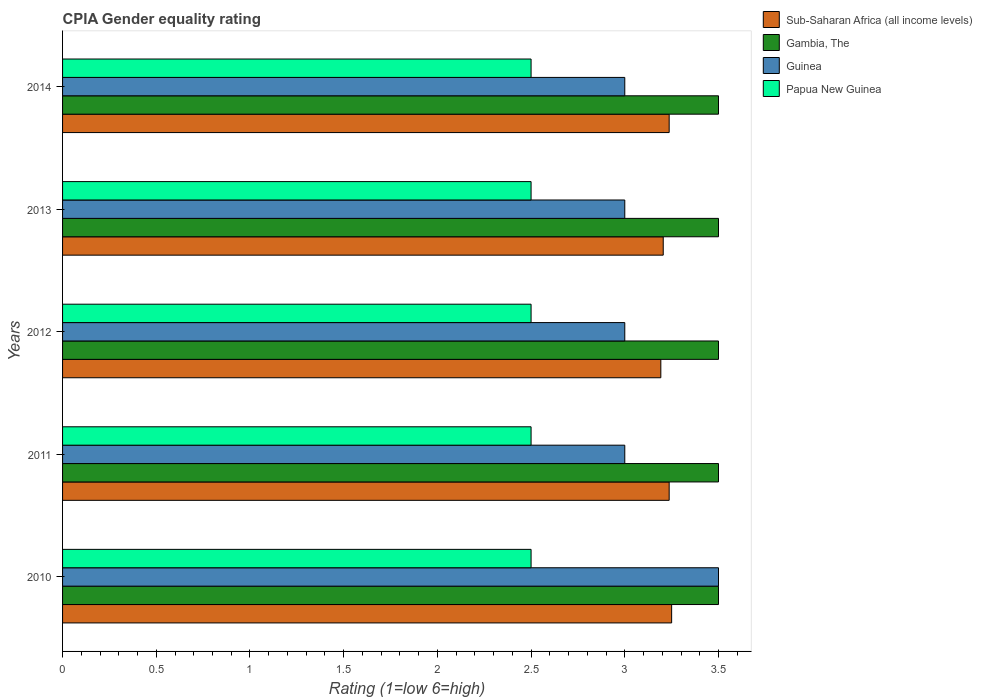How many different coloured bars are there?
Offer a terse response. 4. Are the number of bars per tick equal to the number of legend labels?
Your response must be concise. Yes. Are the number of bars on each tick of the Y-axis equal?
Offer a terse response. Yes. In how many cases, is the number of bars for a given year not equal to the number of legend labels?
Give a very brief answer. 0. Across all years, what is the minimum CPIA rating in Gambia, The?
Your answer should be compact. 3.5. What is the total CPIA rating in Sub-Saharan Africa (all income levels) in the graph?
Offer a very short reply. 16.12. What is the difference between the CPIA rating in Sub-Saharan Africa (all income levels) in 2011 and that in 2012?
Provide a short and direct response. 0.04. In the year 2014, what is the difference between the CPIA rating in Sub-Saharan Africa (all income levels) and CPIA rating in Papua New Guinea?
Provide a succinct answer. 0.74. What is the ratio of the CPIA rating in Guinea in 2011 to that in 2013?
Your response must be concise. 1. Is the CPIA rating in Papua New Guinea in 2010 less than that in 2014?
Keep it short and to the point. No. Is the difference between the CPIA rating in Sub-Saharan Africa (all income levels) in 2011 and 2013 greater than the difference between the CPIA rating in Papua New Guinea in 2011 and 2013?
Your answer should be very brief. Yes. What is the difference between the highest and the second highest CPIA rating in Sub-Saharan Africa (all income levels)?
Your response must be concise. 0.01. What is the difference between the highest and the lowest CPIA rating in Sub-Saharan Africa (all income levels)?
Make the answer very short. 0.06. In how many years, is the CPIA rating in Sub-Saharan Africa (all income levels) greater than the average CPIA rating in Sub-Saharan Africa (all income levels) taken over all years?
Provide a succinct answer. 3. Is the sum of the CPIA rating in Gambia, The in 2012 and 2013 greater than the maximum CPIA rating in Papua New Guinea across all years?
Offer a very short reply. Yes. What does the 4th bar from the top in 2013 represents?
Offer a very short reply. Sub-Saharan Africa (all income levels). What does the 2nd bar from the bottom in 2012 represents?
Your answer should be very brief. Gambia, The. How many bars are there?
Ensure brevity in your answer.  20. What is the difference between two consecutive major ticks on the X-axis?
Your answer should be compact. 0.5. How many legend labels are there?
Keep it short and to the point. 4. What is the title of the graph?
Give a very brief answer. CPIA Gender equality rating. Does "Bosnia and Herzegovina" appear as one of the legend labels in the graph?
Offer a terse response. No. What is the label or title of the Y-axis?
Keep it short and to the point. Years. What is the Rating (1=low 6=high) in Gambia, The in 2010?
Your answer should be very brief. 3.5. What is the Rating (1=low 6=high) in Sub-Saharan Africa (all income levels) in 2011?
Provide a short and direct response. 3.24. What is the Rating (1=low 6=high) of Gambia, The in 2011?
Your answer should be very brief. 3.5. What is the Rating (1=low 6=high) in Papua New Guinea in 2011?
Your response must be concise. 2.5. What is the Rating (1=low 6=high) of Sub-Saharan Africa (all income levels) in 2012?
Offer a terse response. 3.19. What is the Rating (1=low 6=high) of Guinea in 2012?
Offer a terse response. 3. What is the Rating (1=low 6=high) in Papua New Guinea in 2012?
Your answer should be compact. 2.5. What is the Rating (1=low 6=high) in Sub-Saharan Africa (all income levels) in 2013?
Ensure brevity in your answer.  3.21. What is the Rating (1=low 6=high) in Gambia, The in 2013?
Ensure brevity in your answer.  3.5. What is the Rating (1=low 6=high) in Papua New Guinea in 2013?
Keep it short and to the point. 2.5. What is the Rating (1=low 6=high) of Sub-Saharan Africa (all income levels) in 2014?
Provide a succinct answer. 3.24. What is the Rating (1=low 6=high) of Gambia, The in 2014?
Offer a very short reply. 3.5. Across all years, what is the maximum Rating (1=low 6=high) of Guinea?
Your answer should be very brief. 3.5. Across all years, what is the maximum Rating (1=low 6=high) in Papua New Guinea?
Ensure brevity in your answer.  2.5. Across all years, what is the minimum Rating (1=low 6=high) in Sub-Saharan Africa (all income levels)?
Offer a very short reply. 3.19. Across all years, what is the minimum Rating (1=low 6=high) in Guinea?
Your answer should be compact. 3. What is the total Rating (1=low 6=high) of Sub-Saharan Africa (all income levels) in the graph?
Offer a terse response. 16.12. What is the total Rating (1=low 6=high) of Gambia, The in the graph?
Ensure brevity in your answer.  17.5. What is the difference between the Rating (1=low 6=high) in Sub-Saharan Africa (all income levels) in 2010 and that in 2011?
Provide a short and direct response. 0.01. What is the difference between the Rating (1=low 6=high) of Guinea in 2010 and that in 2011?
Your response must be concise. 0.5. What is the difference between the Rating (1=low 6=high) of Sub-Saharan Africa (all income levels) in 2010 and that in 2012?
Provide a succinct answer. 0.06. What is the difference between the Rating (1=low 6=high) of Gambia, The in 2010 and that in 2012?
Provide a short and direct response. 0. What is the difference between the Rating (1=low 6=high) of Guinea in 2010 and that in 2012?
Offer a very short reply. 0.5. What is the difference between the Rating (1=low 6=high) of Papua New Guinea in 2010 and that in 2012?
Your answer should be very brief. 0. What is the difference between the Rating (1=low 6=high) in Sub-Saharan Africa (all income levels) in 2010 and that in 2013?
Make the answer very short. 0.04. What is the difference between the Rating (1=low 6=high) in Gambia, The in 2010 and that in 2013?
Ensure brevity in your answer.  0. What is the difference between the Rating (1=low 6=high) in Guinea in 2010 and that in 2013?
Keep it short and to the point. 0.5. What is the difference between the Rating (1=low 6=high) of Papua New Guinea in 2010 and that in 2013?
Provide a succinct answer. 0. What is the difference between the Rating (1=low 6=high) in Sub-Saharan Africa (all income levels) in 2010 and that in 2014?
Your response must be concise. 0.01. What is the difference between the Rating (1=low 6=high) of Sub-Saharan Africa (all income levels) in 2011 and that in 2012?
Your answer should be very brief. 0.04. What is the difference between the Rating (1=low 6=high) of Guinea in 2011 and that in 2012?
Keep it short and to the point. 0. What is the difference between the Rating (1=low 6=high) in Sub-Saharan Africa (all income levels) in 2011 and that in 2013?
Keep it short and to the point. 0.03. What is the difference between the Rating (1=low 6=high) of Gambia, The in 2011 and that in 2013?
Your answer should be compact. 0. What is the difference between the Rating (1=low 6=high) in Guinea in 2011 and that in 2013?
Your answer should be compact. 0. What is the difference between the Rating (1=low 6=high) in Papua New Guinea in 2011 and that in 2013?
Offer a terse response. 0. What is the difference between the Rating (1=low 6=high) of Sub-Saharan Africa (all income levels) in 2011 and that in 2014?
Provide a short and direct response. 0. What is the difference between the Rating (1=low 6=high) of Gambia, The in 2011 and that in 2014?
Offer a very short reply. 0. What is the difference between the Rating (1=low 6=high) of Papua New Guinea in 2011 and that in 2014?
Offer a terse response. 0. What is the difference between the Rating (1=low 6=high) of Sub-Saharan Africa (all income levels) in 2012 and that in 2013?
Give a very brief answer. -0.01. What is the difference between the Rating (1=low 6=high) in Sub-Saharan Africa (all income levels) in 2012 and that in 2014?
Keep it short and to the point. -0.04. What is the difference between the Rating (1=low 6=high) in Gambia, The in 2012 and that in 2014?
Your answer should be very brief. 0. What is the difference between the Rating (1=low 6=high) in Papua New Guinea in 2012 and that in 2014?
Make the answer very short. 0. What is the difference between the Rating (1=low 6=high) in Sub-Saharan Africa (all income levels) in 2013 and that in 2014?
Ensure brevity in your answer.  -0.03. What is the difference between the Rating (1=low 6=high) of Gambia, The in 2013 and that in 2014?
Give a very brief answer. 0. What is the difference between the Rating (1=low 6=high) in Papua New Guinea in 2013 and that in 2014?
Your answer should be very brief. 0. What is the difference between the Rating (1=low 6=high) of Sub-Saharan Africa (all income levels) in 2010 and the Rating (1=low 6=high) of Gambia, The in 2011?
Offer a terse response. -0.25. What is the difference between the Rating (1=low 6=high) in Sub-Saharan Africa (all income levels) in 2010 and the Rating (1=low 6=high) in Guinea in 2011?
Offer a very short reply. 0.25. What is the difference between the Rating (1=low 6=high) of Sub-Saharan Africa (all income levels) in 2010 and the Rating (1=low 6=high) of Papua New Guinea in 2011?
Keep it short and to the point. 0.75. What is the difference between the Rating (1=low 6=high) of Guinea in 2010 and the Rating (1=low 6=high) of Papua New Guinea in 2011?
Provide a short and direct response. 1. What is the difference between the Rating (1=low 6=high) of Sub-Saharan Africa (all income levels) in 2010 and the Rating (1=low 6=high) of Papua New Guinea in 2012?
Give a very brief answer. 0.75. What is the difference between the Rating (1=low 6=high) of Guinea in 2010 and the Rating (1=low 6=high) of Papua New Guinea in 2012?
Offer a very short reply. 1. What is the difference between the Rating (1=low 6=high) in Guinea in 2010 and the Rating (1=low 6=high) in Papua New Guinea in 2013?
Your answer should be compact. 1. What is the difference between the Rating (1=low 6=high) in Sub-Saharan Africa (all income levels) in 2010 and the Rating (1=low 6=high) in Gambia, The in 2014?
Offer a very short reply. -0.25. What is the difference between the Rating (1=low 6=high) of Sub-Saharan Africa (all income levels) in 2010 and the Rating (1=low 6=high) of Papua New Guinea in 2014?
Your response must be concise. 0.75. What is the difference between the Rating (1=low 6=high) in Sub-Saharan Africa (all income levels) in 2011 and the Rating (1=low 6=high) in Gambia, The in 2012?
Your answer should be compact. -0.26. What is the difference between the Rating (1=low 6=high) of Sub-Saharan Africa (all income levels) in 2011 and the Rating (1=low 6=high) of Guinea in 2012?
Keep it short and to the point. 0.24. What is the difference between the Rating (1=low 6=high) in Sub-Saharan Africa (all income levels) in 2011 and the Rating (1=low 6=high) in Papua New Guinea in 2012?
Give a very brief answer. 0.74. What is the difference between the Rating (1=low 6=high) of Gambia, The in 2011 and the Rating (1=low 6=high) of Guinea in 2012?
Keep it short and to the point. 0.5. What is the difference between the Rating (1=low 6=high) in Sub-Saharan Africa (all income levels) in 2011 and the Rating (1=low 6=high) in Gambia, The in 2013?
Ensure brevity in your answer.  -0.26. What is the difference between the Rating (1=low 6=high) in Sub-Saharan Africa (all income levels) in 2011 and the Rating (1=low 6=high) in Guinea in 2013?
Offer a very short reply. 0.24. What is the difference between the Rating (1=low 6=high) of Sub-Saharan Africa (all income levels) in 2011 and the Rating (1=low 6=high) of Papua New Guinea in 2013?
Keep it short and to the point. 0.74. What is the difference between the Rating (1=low 6=high) of Guinea in 2011 and the Rating (1=low 6=high) of Papua New Guinea in 2013?
Offer a terse response. 0.5. What is the difference between the Rating (1=low 6=high) of Sub-Saharan Africa (all income levels) in 2011 and the Rating (1=low 6=high) of Gambia, The in 2014?
Provide a short and direct response. -0.26. What is the difference between the Rating (1=low 6=high) of Sub-Saharan Africa (all income levels) in 2011 and the Rating (1=low 6=high) of Guinea in 2014?
Your answer should be very brief. 0.24. What is the difference between the Rating (1=low 6=high) in Sub-Saharan Africa (all income levels) in 2011 and the Rating (1=low 6=high) in Papua New Guinea in 2014?
Keep it short and to the point. 0.74. What is the difference between the Rating (1=low 6=high) in Gambia, The in 2011 and the Rating (1=low 6=high) in Guinea in 2014?
Your response must be concise. 0.5. What is the difference between the Rating (1=low 6=high) of Gambia, The in 2011 and the Rating (1=low 6=high) of Papua New Guinea in 2014?
Your answer should be very brief. 1. What is the difference between the Rating (1=low 6=high) in Guinea in 2011 and the Rating (1=low 6=high) in Papua New Guinea in 2014?
Make the answer very short. 0.5. What is the difference between the Rating (1=low 6=high) in Sub-Saharan Africa (all income levels) in 2012 and the Rating (1=low 6=high) in Gambia, The in 2013?
Give a very brief answer. -0.31. What is the difference between the Rating (1=low 6=high) in Sub-Saharan Africa (all income levels) in 2012 and the Rating (1=low 6=high) in Guinea in 2013?
Provide a short and direct response. 0.19. What is the difference between the Rating (1=low 6=high) in Sub-Saharan Africa (all income levels) in 2012 and the Rating (1=low 6=high) in Papua New Guinea in 2013?
Offer a very short reply. 0.69. What is the difference between the Rating (1=low 6=high) of Gambia, The in 2012 and the Rating (1=low 6=high) of Guinea in 2013?
Provide a succinct answer. 0.5. What is the difference between the Rating (1=low 6=high) in Guinea in 2012 and the Rating (1=low 6=high) in Papua New Guinea in 2013?
Your response must be concise. 0.5. What is the difference between the Rating (1=low 6=high) in Sub-Saharan Africa (all income levels) in 2012 and the Rating (1=low 6=high) in Gambia, The in 2014?
Offer a very short reply. -0.31. What is the difference between the Rating (1=low 6=high) of Sub-Saharan Africa (all income levels) in 2012 and the Rating (1=low 6=high) of Guinea in 2014?
Provide a short and direct response. 0.19. What is the difference between the Rating (1=low 6=high) in Sub-Saharan Africa (all income levels) in 2012 and the Rating (1=low 6=high) in Papua New Guinea in 2014?
Offer a very short reply. 0.69. What is the difference between the Rating (1=low 6=high) of Gambia, The in 2012 and the Rating (1=low 6=high) of Guinea in 2014?
Keep it short and to the point. 0.5. What is the difference between the Rating (1=low 6=high) of Guinea in 2012 and the Rating (1=low 6=high) of Papua New Guinea in 2014?
Make the answer very short. 0.5. What is the difference between the Rating (1=low 6=high) in Sub-Saharan Africa (all income levels) in 2013 and the Rating (1=low 6=high) in Gambia, The in 2014?
Offer a terse response. -0.29. What is the difference between the Rating (1=low 6=high) in Sub-Saharan Africa (all income levels) in 2013 and the Rating (1=low 6=high) in Guinea in 2014?
Offer a terse response. 0.21. What is the difference between the Rating (1=low 6=high) of Sub-Saharan Africa (all income levels) in 2013 and the Rating (1=low 6=high) of Papua New Guinea in 2014?
Your answer should be compact. 0.71. What is the difference between the Rating (1=low 6=high) in Gambia, The in 2013 and the Rating (1=low 6=high) in Guinea in 2014?
Give a very brief answer. 0.5. What is the difference between the Rating (1=low 6=high) in Gambia, The in 2013 and the Rating (1=low 6=high) in Papua New Guinea in 2014?
Make the answer very short. 1. What is the difference between the Rating (1=low 6=high) in Guinea in 2013 and the Rating (1=low 6=high) in Papua New Guinea in 2014?
Ensure brevity in your answer.  0.5. What is the average Rating (1=low 6=high) in Sub-Saharan Africa (all income levels) per year?
Ensure brevity in your answer.  3.22. What is the average Rating (1=low 6=high) of Guinea per year?
Provide a succinct answer. 3.1. In the year 2010, what is the difference between the Rating (1=low 6=high) in Gambia, The and Rating (1=low 6=high) in Papua New Guinea?
Your answer should be compact. 1. In the year 2010, what is the difference between the Rating (1=low 6=high) of Guinea and Rating (1=low 6=high) of Papua New Guinea?
Provide a short and direct response. 1. In the year 2011, what is the difference between the Rating (1=low 6=high) of Sub-Saharan Africa (all income levels) and Rating (1=low 6=high) of Gambia, The?
Offer a very short reply. -0.26. In the year 2011, what is the difference between the Rating (1=low 6=high) in Sub-Saharan Africa (all income levels) and Rating (1=low 6=high) in Guinea?
Give a very brief answer. 0.24. In the year 2011, what is the difference between the Rating (1=low 6=high) in Sub-Saharan Africa (all income levels) and Rating (1=low 6=high) in Papua New Guinea?
Offer a terse response. 0.74. In the year 2011, what is the difference between the Rating (1=low 6=high) of Gambia, The and Rating (1=low 6=high) of Papua New Guinea?
Make the answer very short. 1. In the year 2011, what is the difference between the Rating (1=low 6=high) of Guinea and Rating (1=low 6=high) of Papua New Guinea?
Your answer should be compact. 0.5. In the year 2012, what is the difference between the Rating (1=low 6=high) in Sub-Saharan Africa (all income levels) and Rating (1=low 6=high) in Gambia, The?
Ensure brevity in your answer.  -0.31. In the year 2012, what is the difference between the Rating (1=low 6=high) in Sub-Saharan Africa (all income levels) and Rating (1=low 6=high) in Guinea?
Your answer should be very brief. 0.19. In the year 2012, what is the difference between the Rating (1=low 6=high) in Sub-Saharan Africa (all income levels) and Rating (1=low 6=high) in Papua New Guinea?
Offer a very short reply. 0.69. In the year 2012, what is the difference between the Rating (1=low 6=high) of Gambia, The and Rating (1=low 6=high) of Guinea?
Provide a short and direct response. 0.5. In the year 2012, what is the difference between the Rating (1=low 6=high) in Guinea and Rating (1=low 6=high) in Papua New Guinea?
Offer a terse response. 0.5. In the year 2013, what is the difference between the Rating (1=low 6=high) of Sub-Saharan Africa (all income levels) and Rating (1=low 6=high) of Gambia, The?
Offer a terse response. -0.29. In the year 2013, what is the difference between the Rating (1=low 6=high) of Sub-Saharan Africa (all income levels) and Rating (1=low 6=high) of Guinea?
Ensure brevity in your answer.  0.21. In the year 2013, what is the difference between the Rating (1=low 6=high) in Sub-Saharan Africa (all income levels) and Rating (1=low 6=high) in Papua New Guinea?
Provide a short and direct response. 0.71. In the year 2013, what is the difference between the Rating (1=low 6=high) of Gambia, The and Rating (1=low 6=high) of Guinea?
Your response must be concise. 0.5. In the year 2013, what is the difference between the Rating (1=low 6=high) of Gambia, The and Rating (1=low 6=high) of Papua New Guinea?
Give a very brief answer. 1. In the year 2013, what is the difference between the Rating (1=low 6=high) in Guinea and Rating (1=low 6=high) in Papua New Guinea?
Ensure brevity in your answer.  0.5. In the year 2014, what is the difference between the Rating (1=low 6=high) in Sub-Saharan Africa (all income levels) and Rating (1=low 6=high) in Gambia, The?
Provide a succinct answer. -0.26. In the year 2014, what is the difference between the Rating (1=low 6=high) in Sub-Saharan Africa (all income levels) and Rating (1=low 6=high) in Guinea?
Give a very brief answer. 0.24. In the year 2014, what is the difference between the Rating (1=low 6=high) of Sub-Saharan Africa (all income levels) and Rating (1=low 6=high) of Papua New Guinea?
Keep it short and to the point. 0.74. In the year 2014, what is the difference between the Rating (1=low 6=high) of Gambia, The and Rating (1=low 6=high) of Guinea?
Provide a succinct answer. 0.5. In the year 2014, what is the difference between the Rating (1=low 6=high) in Gambia, The and Rating (1=low 6=high) in Papua New Guinea?
Give a very brief answer. 1. In the year 2014, what is the difference between the Rating (1=low 6=high) in Guinea and Rating (1=low 6=high) in Papua New Guinea?
Your response must be concise. 0.5. What is the ratio of the Rating (1=low 6=high) in Gambia, The in 2010 to that in 2011?
Provide a succinct answer. 1. What is the ratio of the Rating (1=low 6=high) in Guinea in 2010 to that in 2011?
Your answer should be very brief. 1.17. What is the ratio of the Rating (1=low 6=high) in Sub-Saharan Africa (all income levels) in 2010 to that in 2012?
Your answer should be very brief. 1.02. What is the ratio of the Rating (1=low 6=high) of Guinea in 2010 to that in 2012?
Your response must be concise. 1.17. What is the ratio of the Rating (1=low 6=high) in Gambia, The in 2010 to that in 2013?
Make the answer very short. 1. What is the ratio of the Rating (1=low 6=high) of Guinea in 2010 to that in 2013?
Provide a succinct answer. 1.17. What is the ratio of the Rating (1=low 6=high) in Papua New Guinea in 2010 to that in 2013?
Offer a very short reply. 1. What is the ratio of the Rating (1=low 6=high) of Gambia, The in 2010 to that in 2014?
Provide a short and direct response. 1. What is the ratio of the Rating (1=low 6=high) of Papua New Guinea in 2010 to that in 2014?
Offer a terse response. 1. What is the ratio of the Rating (1=low 6=high) in Sub-Saharan Africa (all income levels) in 2011 to that in 2012?
Your answer should be very brief. 1.01. What is the ratio of the Rating (1=low 6=high) of Gambia, The in 2011 to that in 2012?
Provide a succinct answer. 1. What is the ratio of the Rating (1=low 6=high) in Papua New Guinea in 2011 to that in 2012?
Your response must be concise. 1. What is the ratio of the Rating (1=low 6=high) in Sub-Saharan Africa (all income levels) in 2011 to that in 2013?
Make the answer very short. 1.01. What is the ratio of the Rating (1=low 6=high) in Gambia, The in 2011 to that in 2013?
Keep it short and to the point. 1. What is the ratio of the Rating (1=low 6=high) of Papua New Guinea in 2011 to that in 2013?
Your response must be concise. 1. What is the ratio of the Rating (1=low 6=high) of Gambia, The in 2011 to that in 2014?
Give a very brief answer. 1. What is the ratio of the Rating (1=low 6=high) of Papua New Guinea in 2011 to that in 2014?
Offer a very short reply. 1. What is the ratio of the Rating (1=low 6=high) in Sub-Saharan Africa (all income levels) in 2012 to that in 2013?
Offer a terse response. 1. What is the ratio of the Rating (1=low 6=high) in Gambia, The in 2012 to that in 2013?
Give a very brief answer. 1. What is the ratio of the Rating (1=low 6=high) of Papua New Guinea in 2012 to that in 2013?
Provide a succinct answer. 1. What is the ratio of the Rating (1=low 6=high) of Sub-Saharan Africa (all income levels) in 2012 to that in 2014?
Offer a terse response. 0.99. What is the ratio of the Rating (1=low 6=high) of Gambia, The in 2012 to that in 2014?
Provide a short and direct response. 1. What is the ratio of the Rating (1=low 6=high) of Papua New Guinea in 2012 to that in 2014?
Keep it short and to the point. 1. What is the ratio of the Rating (1=low 6=high) of Sub-Saharan Africa (all income levels) in 2013 to that in 2014?
Provide a short and direct response. 0.99. What is the ratio of the Rating (1=low 6=high) of Gambia, The in 2013 to that in 2014?
Ensure brevity in your answer.  1. What is the ratio of the Rating (1=low 6=high) in Papua New Guinea in 2013 to that in 2014?
Ensure brevity in your answer.  1. What is the difference between the highest and the second highest Rating (1=low 6=high) in Sub-Saharan Africa (all income levels)?
Provide a succinct answer. 0.01. What is the difference between the highest and the lowest Rating (1=low 6=high) in Sub-Saharan Africa (all income levels)?
Your response must be concise. 0.06. What is the difference between the highest and the lowest Rating (1=low 6=high) of Gambia, The?
Offer a very short reply. 0. What is the difference between the highest and the lowest Rating (1=low 6=high) of Papua New Guinea?
Offer a terse response. 0. 